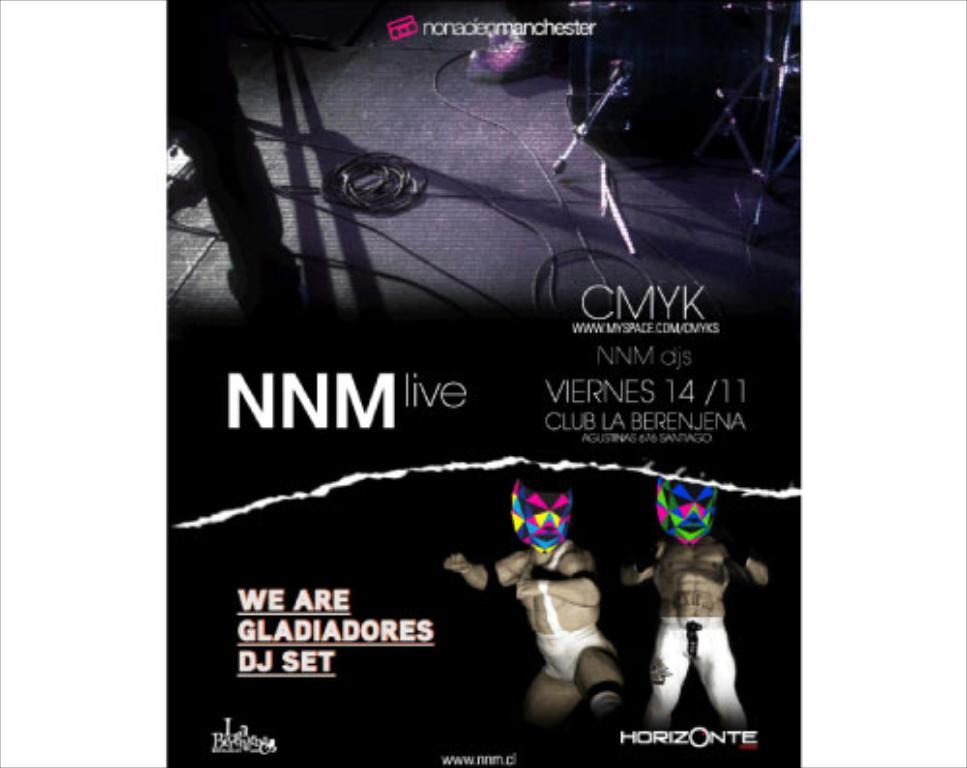<image>
Summarize the visual content of the image. A poster for NNM live with two character posing over a Horizonte sign 